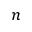Convert formula to latex. <formula><loc_0><loc_0><loc_500><loc_500>n</formula> 